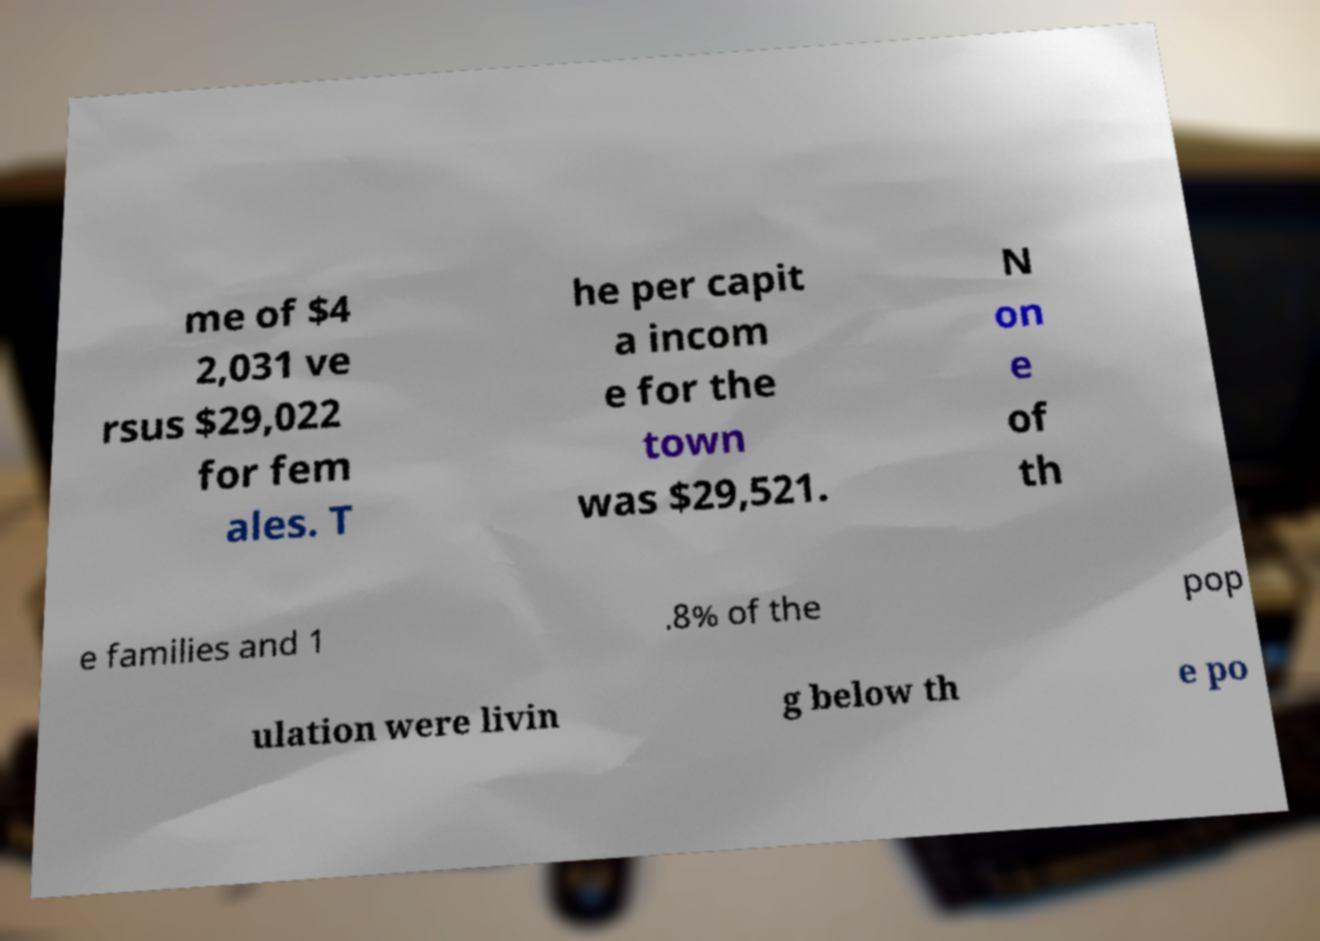Can you read and provide the text displayed in the image?This photo seems to have some interesting text. Can you extract and type it out for me? me of $4 2,031 ve rsus $29,022 for fem ales. T he per capit a incom e for the town was $29,521. N on e of th e families and 1 .8% of the pop ulation were livin g below th e po 